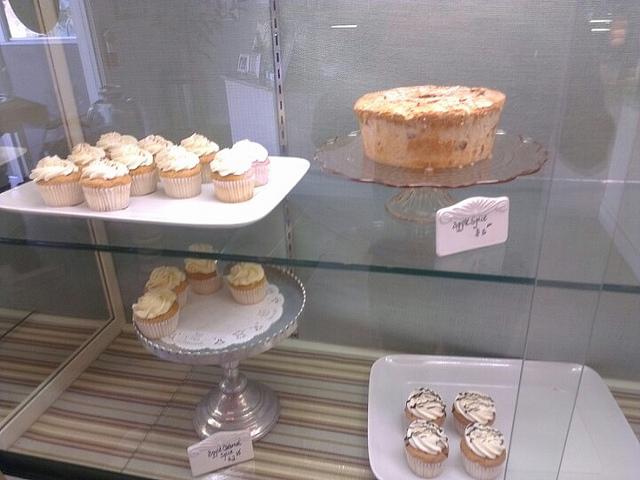How many racks of donuts are there?
Be succinct. 0. Is the cake frosted?
Give a very brief answer. No. What is the shelf made of?
Answer briefly. Glass. How many cupcakes?
Keep it brief. 18. Is this a bakery window?
Answer briefly. Yes. How many cakes are pink?
Give a very brief answer. 1. 